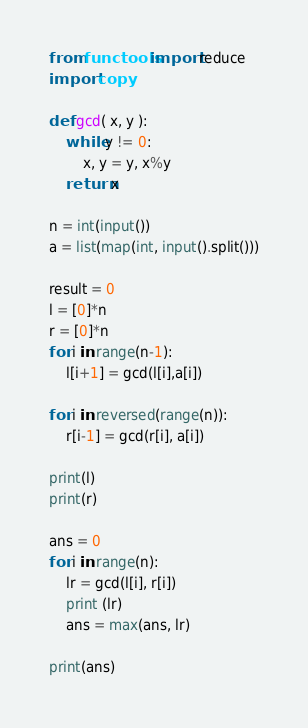Convert code to text. <code><loc_0><loc_0><loc_500><loc_500><_Python_>from functools import reduce
import copy

def gcd( x, y ):
    while y != 0:
        x, y = y, x%y
    return x

n = int(input())
a = list(map(int, input().split()))

result = 0
l = [0]*n
r = [0]*n
for i in range(n-1):
    l[i+1] = gcd(l[i],a[i])

for i in reversed(range(n)):
    r[i-1] = gcd(r[i], a[i])

print(l)
print(r)

ans = 0
for i in range(n):
    lr = gcd(l[i], r[i])
    print (lr)
    ans = max(ans, lr)

print(ans)
</code> 